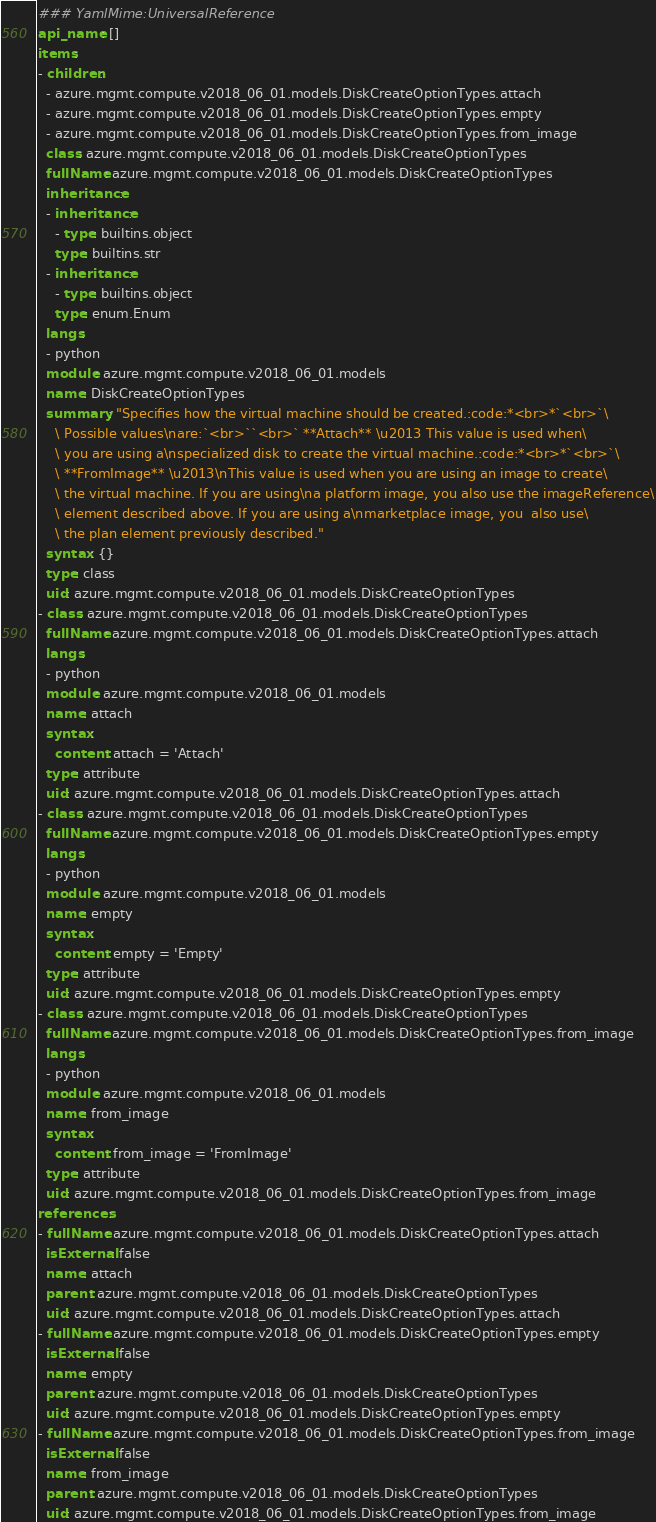Convert code to text. <code><loc_0><loc_0><loc_500><loc_500><_YAML_>### YamlMime:UniversalReference
api_name: []
items:
- children:
  - azure.mgmt.compute.v2018_06_01.models.DiskCreateOptionTypes.attach
  - azure.mgmt.compute.v2018_06_01.models.DiskCreateOptionTypes.empty
  - azure.mgmt.compute.v2018_06_01.models.DiskCreateOptionTypes.from_image
  class: azure.mgmt.compute.v2018_06_01.models.DiskCreateOptionTypes
  fullName: azure.mgmt.compute.v2018_06_01.models.DiskCreateOptionTypes
  inheritance:
  - inheritance:
    - type: builtins.object
    type: builtins.str
  - inheritance:
    - type: builtins.object
    type: enum.Enum
  langs:
  - python
  module: azure.mgmt.compute.v2018_06_01.models
  name: DiskCreateOptionTypes
  summary: "Specifies how the virtual machine should be created.:code:*<br>*`<br>`\
    \ Possible values\nare:`<br>``<br>` **Attach** \u2013 This value is used when\
    \ you are using a\nspecialized disk to create the virtual machine.:code:*<br>*`<br>`\
    \ **FromImage** \u2013\nThis value is used when you are using an image to create\
    \ the virtual machine. If you are using\na platform image, you also use the imageReference\
    \ element described above. If you are using a\nmarketplace image, you  also use\
    \ the plan element previously described."
  syntax: {}
  type: class
  uid: azure.mgmt.compute.v2018_06_01.models.DiskCreateOptionTypes
- class: azure.mgmt.compute.v2018_06_01.models.DiskCreateOptionTypes
  fullName: azure.mgmt.compute.v2018_06_01.models.DiskCreateOptionTypes.attach
  langs:
  - python
  module: azure.mgmt.compute.v2018_06_01.models
  name: attach
  syntax:
    content: attach = 'Attach'
  type: attribute
  uid: azure.mgmt.compute.v2018_06_01.models.DiskCreateOptionTypes.attach
- class: azure.mgmt.compute.v2018_06_01.models.DiskCreateOptionTypes
  fullName: azure.mgmt.compute.v2018_06_01.models.DiskCreateOptionTypes.empty
  langs:
  - python
  module: azure.mgmt.compute.v2018_06_01.models
  name: empty
  syntax:
    content: empty = 'Empty'
  type: attribute
  uid: azure.mgmt.compute.v2018_06_01.models.DiskCreateOptionTypes.empty
- class: azure.mgmt.compute.v2018_06_01.models.DiskCreateOptionTypes
  fullName: azure.mgmt.compute.v2018_06_01.models.DiskCreateOptionTypes.from_image
  langs:
  - python
  module: azure.mgmt.compute.v2018_06_01.models
  name: from_image
  syntax:
    content: from_image = 'FromImage'
  type: attribute
  uid: azure.mgmt.compute.v2018_06_01.models.DiskCreateOptionTypes.from_image
references:
- fullName: azure.mgmt.compute.v2018_06_01.models.DiskCreateOptionTypes.attach
  isExternal: false
  name: attach
  parent: azure.mgmt.compute.v2018_06_01.models.DiskCreateOptionTypes
  uid: azure.mgmt.compute.v2018_06_01.models.DiskCreateOptionTypes.attach
- fullName: azure.mgmt.compute.v2018_06_01.models.DiskCreateOptionTypes.empty
  isExternal: false
  name: empty
  parent: azure.mgmt.compute.v2018_06_01.models.DiskCreateOptionTypes
  uid: azure.mgmt.compute.v2018_06_01.models.DiskCreateOptionTypes.empty
- fullName: azure.mgmt.compute.v2018_06_01.models.DiskCreateOptionTypes.from_image
  isExternal: false
  name: from_image
  parent: azure.mgmt.compute.v2018_06_01.models.DiskCreateOptionTypes
  uid: azure.mgmt.compute.v2018_06_01.models.DiskCreateOptionTypes.from_image
</code> 